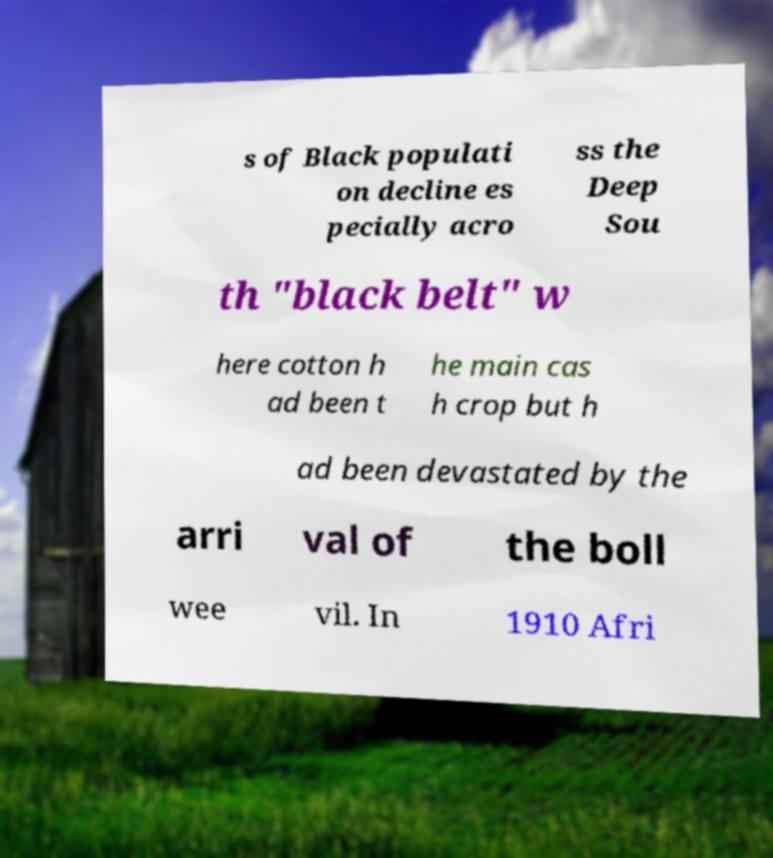Could you assist in decoding the text presented in this image and type it out clearly? s of Black populati on decline es pecially acro ss the Deep Sou th "black belt" w here cotton h ad been t he main cas h crop but h ad been devastated by the arri val of the boll wee vil. In 1910 Afri 